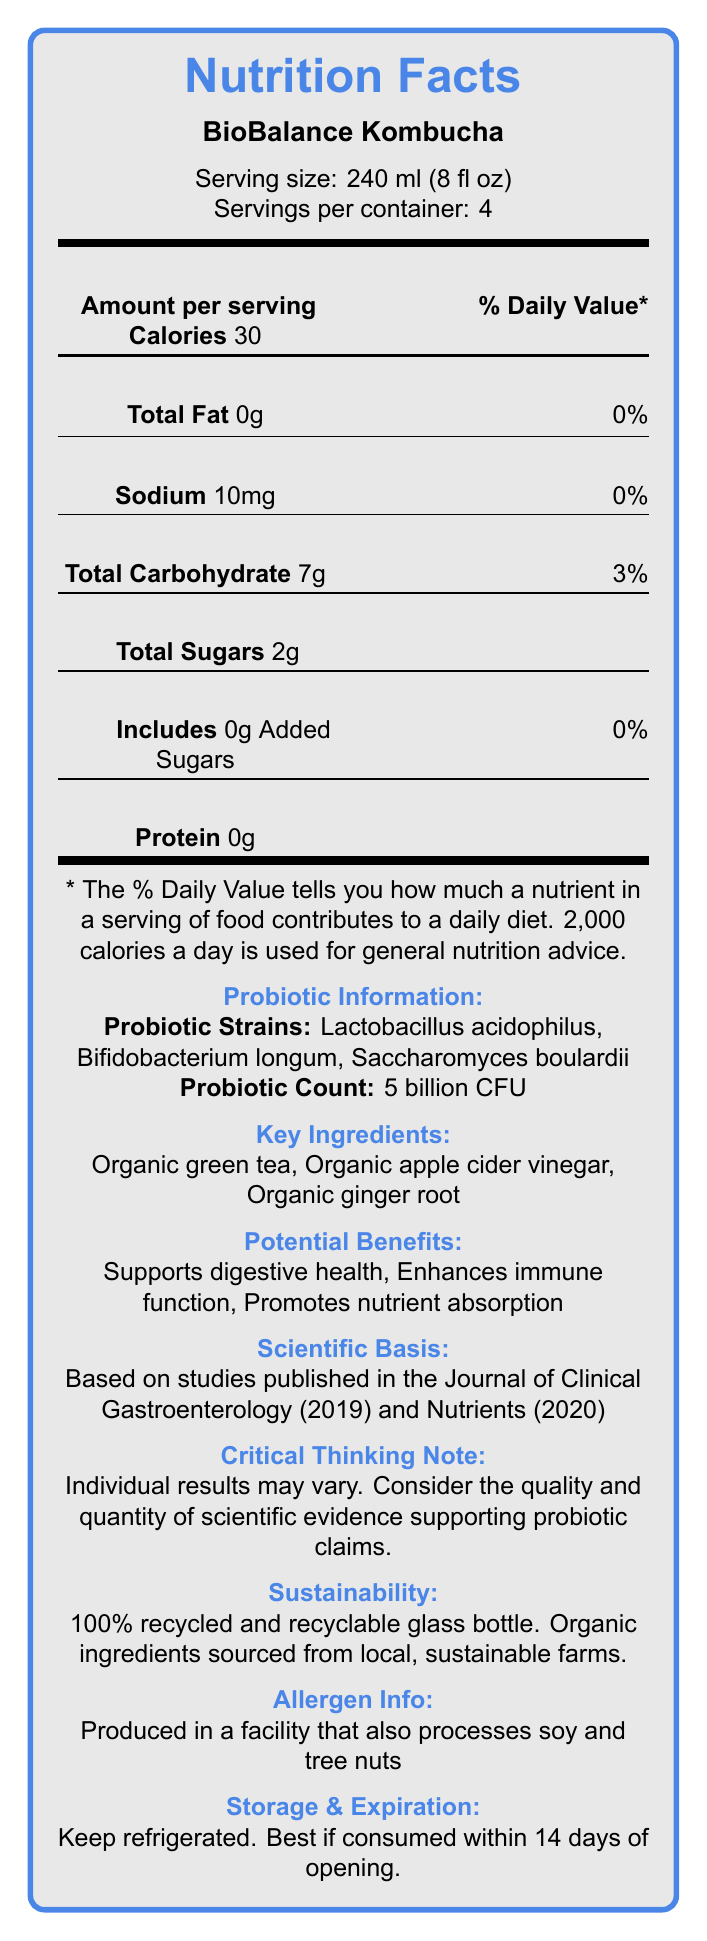What is the product name? The product name is clearly given as "BioBalance Kombucha" at the beginning of the document.
Answer: BioBalance Kombucha What are the probiotic strains included in BioBalance Kombucha? The document lists the probiotic strains under the section "Probiotic Strains."
Answer: Lactobacillus acidophilus, Bifidobacterium longum, Saccharomyces boulardii How many servings are there per container? It is stated "Servings per container: 4" in the document.
Answer: 4 servings What is the probiotic count in BioBalance Kombucha? The probiotic count is mentioned as "5 billion CFU" in the section about probiotics.
Answer: 5 billion CFU What is the serving size of BioBalance Kombucha? The serving size is specified as "240 ml (8 fl oz)" in the document.
Answer: 240 ml (8 fl oz) How many calories are there per serving? The amount of calories per serving is listed as "Calories 30."
Answer: 30 calories Which journal published the study titled "Probiotics and gut health: A systematic review"? A. Journal of Nutrition B. Journal of Clinical Gastroenterology C. Journal of Gut Health The study titled "Probiotics and gut health: A systematic review" was published in the Journal of Clinical Gastroenterology.
Answer: B Which ingredient is NOT a key ingredient in BioBalance Kombucha?
1. Organic green tea
2. Organic apple cider vinegar
3. Organic turmeric
4. Organic ginger root The key ingredients listed are "Organic green tea," "Organic apple cider vinegar," and "Organic ginger root," but not "Organic turmeric."
Answer: 3 Is there any added sugar in BioBalance Kombucha? The label states that the product includes "0g Added Sugars."
Answer: No Is BioBalance Kombucha produced in a facility that processes tree nuts? The allergen info indicates that it is "Produced in a facility that also processes soy and tree nuts."
Answer: Yes Summarize the main information from the BioBalance Kombucha Nutrition Facts Label. This summary captures all primary elements of the BioBalance Kombucha label, including nutritional content, probiotics, key ingredients, benefits, sustainability, and storage details.
Answer: BioBalance Kombucha is a probiotic-rich fermented beverage with 30 calories per serving (240 ml). It contains no fat, minimal sodium (10mg), 7g of carbohydrates, and 2g of sugars (none added). The drink includes probiotic strains such as Lactobacillus acidophilus, Bifidobacterium longum, and Saccharomyces boulardii, amounting to 5 billion CFU. Key ingredients are organic green tea, apple cider vinegar, and ginger root, offering potential benefits like digestive support, immune enhancement, and nutrient absorption. The product uses sustainable packaging and should be refrigerated, consumed within 14 days of opening, and is produced in a facility processing soy and tree nuts. What is the sustainability feature of BioBalance Kombucha's packaging? The sustainability section specifies that the packaging is a "100% recycled and recyclable glass bottle."
Answer: 100% recycled and recyclable glass bottle How long is BioBalance Kombucha best consumed after opening? It is mentioned in the storage section that it is "Best if consumed within 14 days of opening."
Answer: 14 days Based on the document, what is the primary benefit claimed of consuming BioBalance Kombucha? One of the potential benefits listed is "Supports digestive health," which is likely a primary benefit given the probiotic content.
Answer: Supports digestive health How is BioBalance Kombucha different from other kombucha drinks in preserving live cultures? The technological innovation section mentions that BioBalance Kombucha uses a "patented cold-filtration process to preserve live probiotic cultures."
Answer: Uses a patented cold-filtration process What is one potential effect of consuming kombucha as per the 2020 Nutrients study? The scientific basis section states that the 2020 study in Nutrients found that "Kombucha consumption is associated with reduced inflammation in the digestive tract."
Answer: Reduced inflammation in the digestive tract What type of tea is used in BioBalance Kombucha? The key ingredients list "Organic green tea" as one of the components.
Answer: Organic green tea What is the percentage of daily value for total carbohydrates per serving? The total carbohydrate section lists "3%" as the daily value percentage.
Answer: 3% What is the primary color used in the design of BioBalance Kombucha's nutrition label? This information is not provided in the visual content of the document; it's an aspect of the design and color which is not textually mentioned.
Answer: Cannot be determined When was the study titled "Probiotics and gut health: A systematic review" published? The scientific basis section states that this study was published in 2019.
Answer: 2019 Where are the organic ingredients for BioBalance Kombucha sourced from? The sustainability section mentions that ingredients are sourced from "local, sustainable farms."
Answer: Local, sustainable farms 